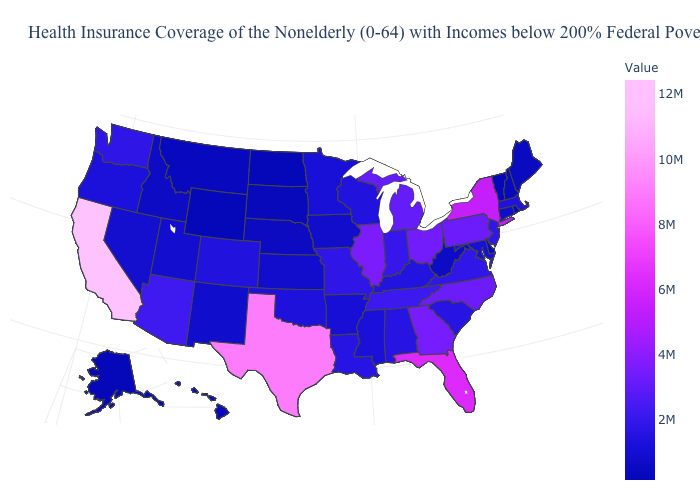Among the states that border Vermont , which have the highest value?
Be succinct. New York. Which states have the lowest value in the USA?
Be succinct. North Dakota. Does Idaho have the highest value in the USA?
Give a very brief answer. No. Does Mississippi have the lowest value in the USA?
Write a very short answer. No. Does Wyoming have the highest value in the West?
Concise answer only. No. Does Missouri have the lowest value in the MidWest?
Quick response, please. No. Among the states that border New York , does Connecticut have the lowest value?
Quick response, please. No. 